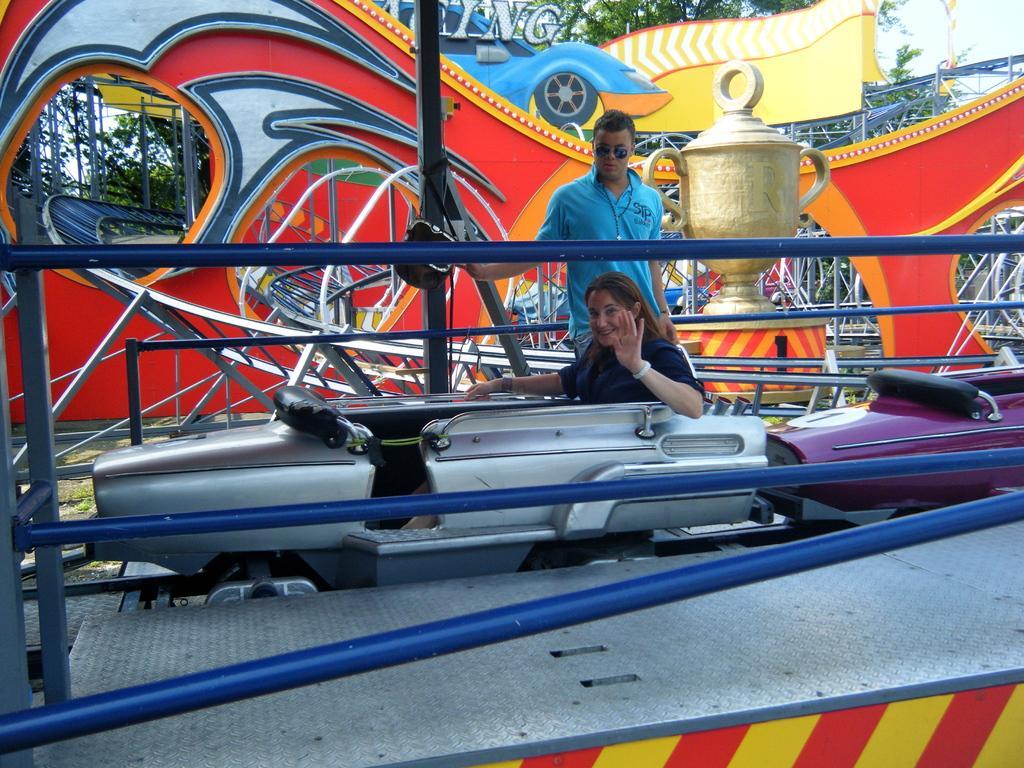Please provide a concise description of this image. This picture shows man standing and few wore sunglasses on their faces and we see a woman seated and we see trees and a cloudy sky. 